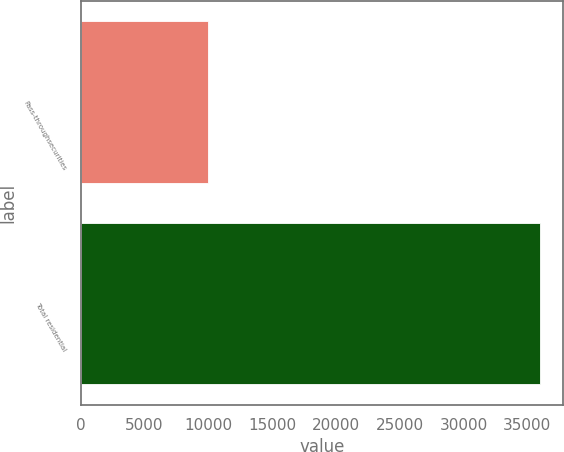<chart> <loc_0><loc_0><loc_500><loc_500><bar_chart><fcel>Pass-throughsecurities<fcel>Total residential<nl><fcel>10003<fcel>36028<nl></chart> 